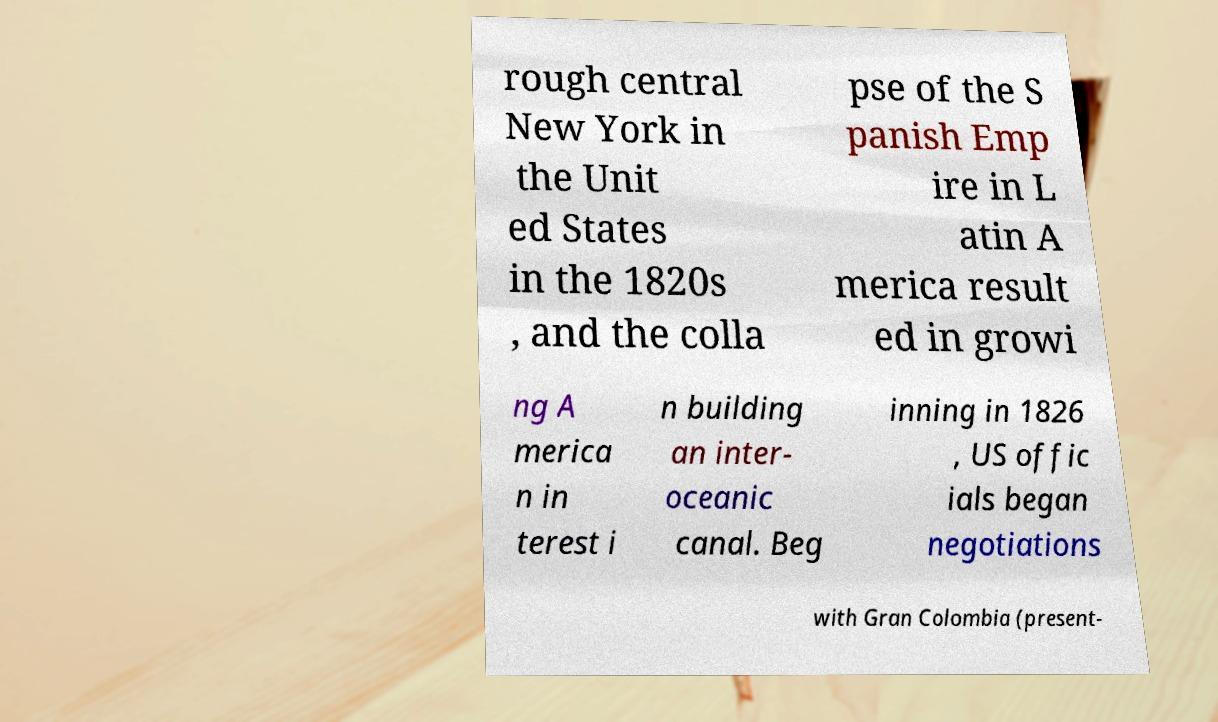For documentation purposes, I need the text within this image transcribed. Could you provide that? rough central New York in the Unit ed States in the 1820s , and the colla pse of the S panish Emp ire in L atin A merica result ed in growi ng A merica n in terest i n building an inter- oceanic canal. Beg inning in 1826 , US offic ials began negotiations with Gran Colombia (present- 